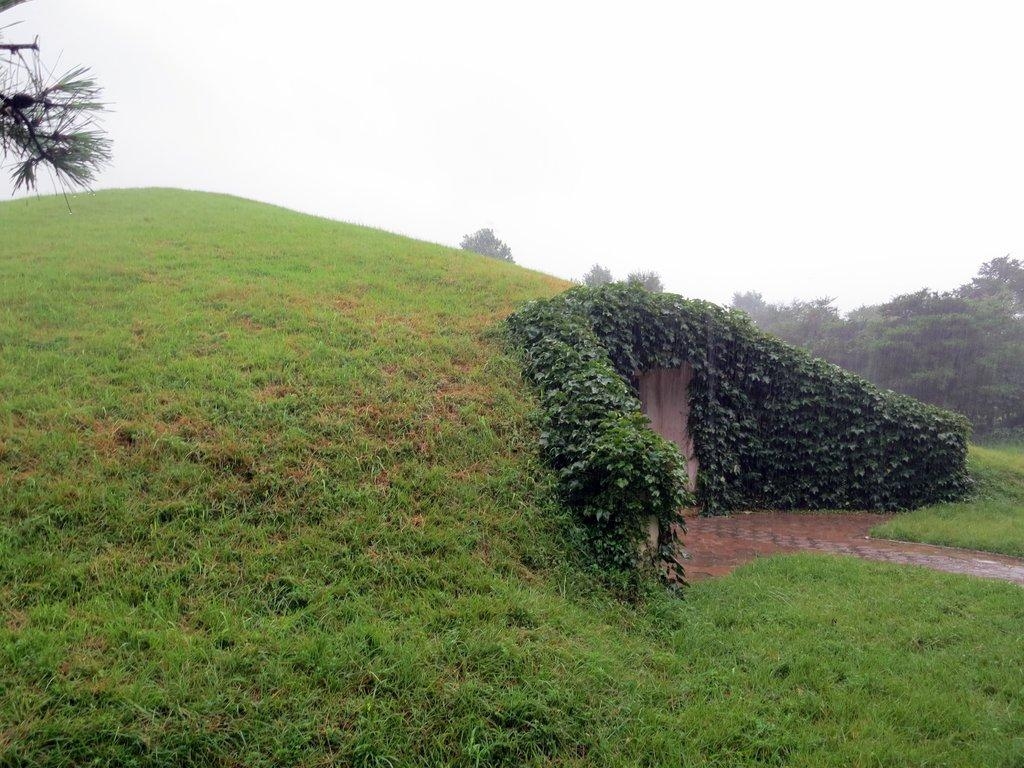Where was the image taken? The image was clicked outside the city. What can be seen in the foreground of the image? There is green grass and a hill in the foreground of the image. What is visible in the background of the image? There is a sky and trees visible in the background of the image. How many planes can be seen flying in the sky in the image? There are no planes visible in the sky in the image. What type of nail is being used to hold the trees in the background? There is no nail present in the image, and the trees are not being held by any visible object. 